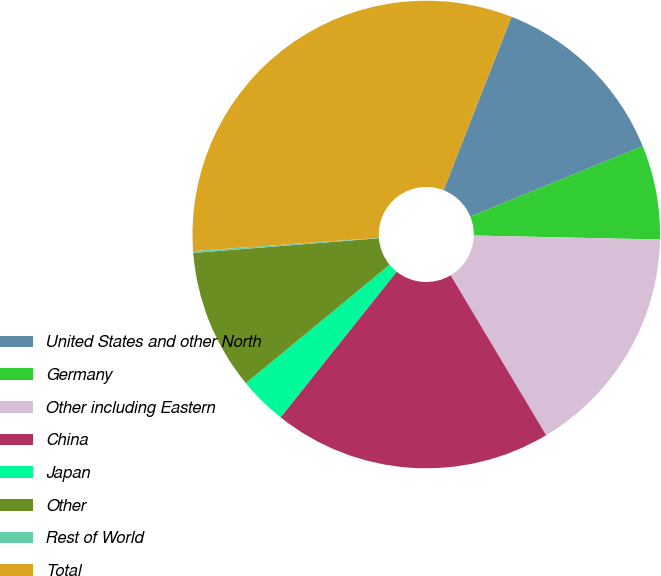Convert chart. <chart><loc_0><loc_0><loc_500><loc_500><pie_chart><fcel>United States and other North<fcel>Germany<fcel>Other including Eastern<fcel>China<fcel>Japan<fcel>Other<fcel>Rest of World<fcel>Total<nl><fcel>12.9%<fcel>6.51%<fcel>16.09%<fcel>19.28%<fcel>3.32%<fcel>9.71%<fcel>0.13%<fcel>32.06%<nl></chart> 